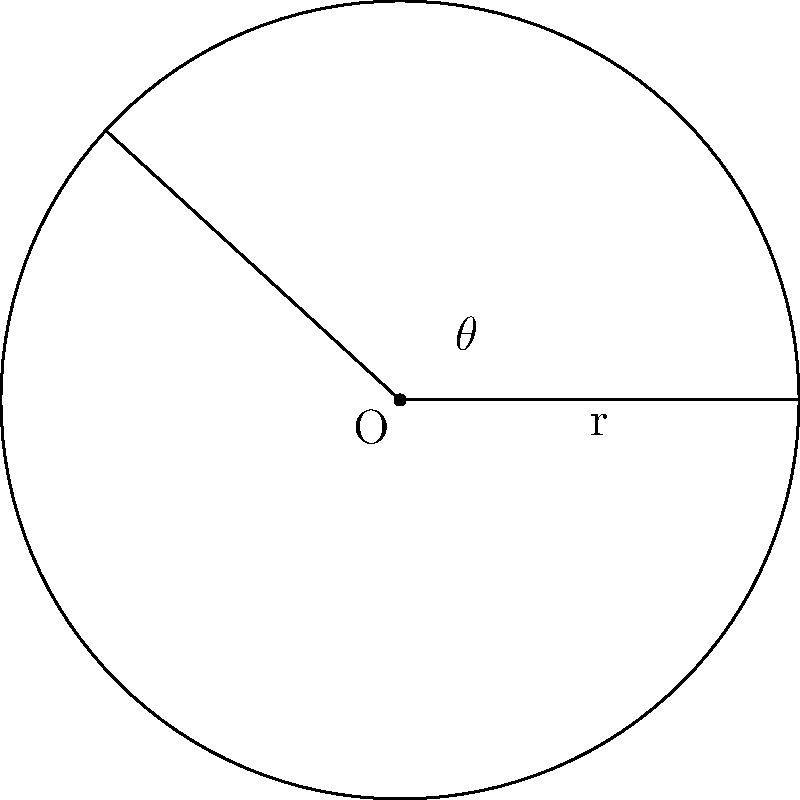In our latest drama series, we're featuring a scene where the protagonist needs to calculate the area of a circular stage prop. The prop is a sector of a circle with radius 5 meters and a central angle of 2.4 radians. As a director known for attention to detail, how would you verify the accuracy of this calculation? Determine the area of this circular sector, rounded to two decimal places. To calculate the area of a circular sector, we'll use the formula:

$$A = \frac{1}{2}r^2\theta$$

Where:
$A$ is the area of the sector
$r$ is the radius of the circle
$\theta$ is the central angle in radians

Given:
$r = 5$ meters
$\theta = 2.4$ radians

Let's substitute these values into our formula:

$$A = \frac{1}{2} \cdot 5^2 \cdot 2.4$$

$$A = \frac{1}{2} \cdot 25 \cdot 2.4$$

$$A = 12.5 \cdot 2.4$$

$$A = 30$$

Therefore, the area of the circular sector is 30 square meters.

Rounding to two decimal places: 30.00 m²
Answer: 30.00 m² 